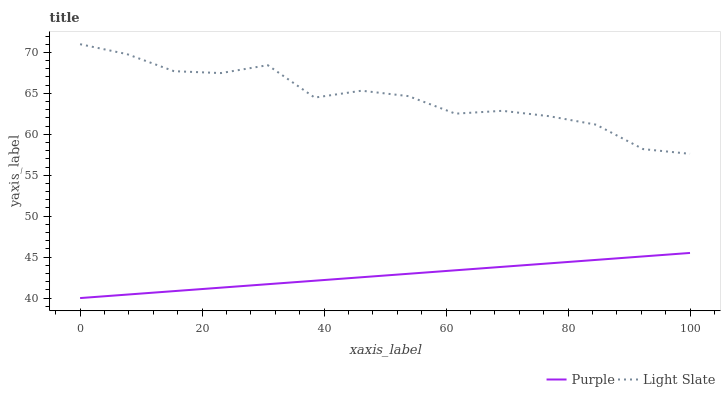Does Light Slate have the minimum area under the curve?
Answer yes or no. No. Is Light Slate the smoothest?
Answer yes or no. No. Does Light Slate have the lowest value?
Answer yes or no. No. Is Purple less than Light Slate?
Answer yes or no. Yes. Is Light Slate greater than Purple?
Answer yes or no. Yes. Does Purple intersect Light Slate?
Answer yes or no. No. 